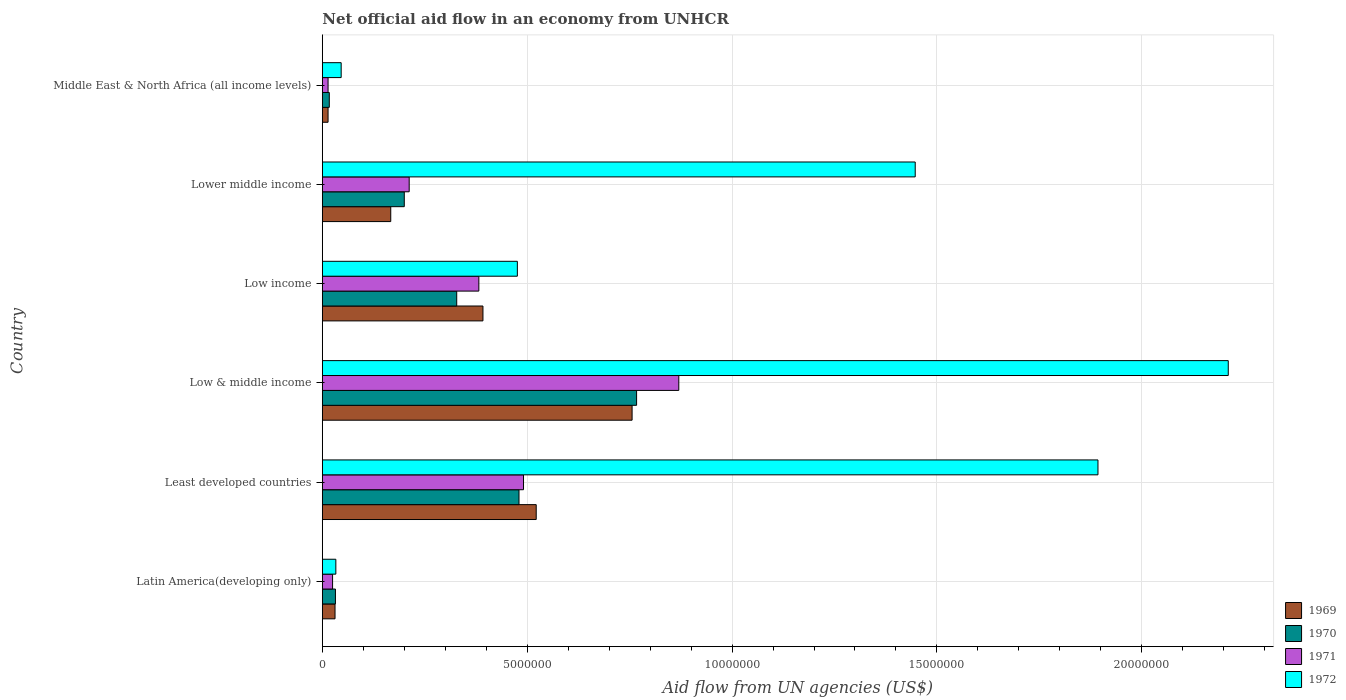How many groups of bars are there?
Provide a succinct answer. 6. Are the number of bars on each tick of the Y-axis equal?
Your response must be concise. Yes. How many bars are there on the 1st tick from the bottom?
Offer a terse response. 4. What is the label of the 1st group of bars from the top?
Ensure brevity in your answer.  Middle East & North Africa (all income levels). What is the net official aid flow in 1972 in Middle East & North Africa (all income levels)?
Offer a terse response. 4.60e+05. Across all countries, what is the maximum net official aid flow in 1969?
Give a very brief answer. 7.56e+06. Across all countries, what is the minimum net official aid flow in 1970?
Your answer should be compact. 1.70e+05. In which country was the net official aid flow in 1971 maximum?
Your answer should be compact. Low & middle income. In which country was the net official aid flow in 1972 minimum?
Give a very brief answer. Latin America(developing only). What is the total net official aid flow in 1971 in the graph?
Offer a very short reply. 1.99e+07. What is the difference between the net official aid flow in 1969 in Low income and that in Middle East & North Africa (all income levels)?
Make the answer very short. 3.78e+06. What is the difference between the net official aid flow in 1970 in Least developed countries and the net official aid flow in 1969 in Low & middle income?
Offer a terse response. -2.76e+06. What is the average net official aid flow in 1972 per country?
Offer a very short reply. 1.02e+07. What is the difference between the net official aid flow in 1970 and net official aid flow in 1971 in Low & middle income?
Make the answer very short. -1.03e+06. In how many countries, is the net official aid flow in 1971 greater than 19000000 US$?
Offer a very short reply. 0. What is the ratio of the net official aid flow in 1971 in Latin America(developing only) to that in Low & middle income?
Ensure brevity in your answer.  0.03. Is the net official aid flow in 1972 in Latin America(developing only) less than that in Least developed countries?
Make the answer very short. Yes. What is the difference between the highest and the second highest net official aid flow in 1969?
Make the answer very short. 2.34e+06. What is the difference between the highest and the lowest net official aid flow in 1972?
Make the answer very short. 2.18e+07. What does the 4th bar from the top in Middle East & North Africa (all income levels) represents?
Offer a very short reply. 1969. What does the 1st bar from the bottom in Lower middle income represents?
Your response must be concise. 1969. Is it the case that in every country, the sum of the net official aid flow in 1969 and net official aid flow in 1970 is greater than the net official aid flow in 1972?
Keep it short and to the point. No. Are all the bars in the graph horizontal?
Your answer should be very brief. Yes. What is the difference between two consecutive major ticks on the X-axis?
Provide a succinct answer. 5.00e+06. Are the values on the major ticks of X-axis written in scientific E-notation?
Your response must be concise. No. Does the graph contain grids?
Your answer should be very brief. Yes. How many legend labels are there?
Provide a short and direct response. 4. How are the legend labels stacked?
Your response must be concise. Vertical. What is the title of the graph?
Offer a terse response. Net official aid flow in an economy from UNHCR. What is the label or title of the X-axis?
Provide a short and direct response. Aid flow from UN agencies (US$). What is the Aid flow from UN agencies (US$) in 1970 in Latin America(developing only)?
Your answer should be very brief. 3.20e+05. What is the Aid flow from UN agencies (US$) of 1969 in Least developed countries?
Offer a terse response. 5.22e+06. What is the Aid flow from UN agencies (US$) in 1970 in Least developed countries?
Offer a very short reply. 4.80e+06. What is the Aid flow from UN agencies (US$) of 1971 in Least developed countries?
Your answer should be very brief. 4.91e+06. What is the Aid flow from UN agencies (US$) in 1972 in Least developed countries?
Give a very brief answer. 1.89e+07. What is the Aid flow from UN agencies (US$) of 1969 in Low & middle income?
Provide a succinct answer. 7.56e+06. What is the Aid flow from UN agencies (US$) of 1970 in Low & middle income?
Make the answer very short. 7.67e+06. What is the Aid flow from UN agencies (US$) of 1971 in Low & middle income?
Ensure brevity in your answer.  8.70e+06. What is the Aid flow from UN agencies (US$) of 1972 in Low & middle income?
Provide a succinct answer. 2.21e+07. What is the Aid flow from UN agencies (US$) of 1969 in Low income?
Offer a terse response. 3.92e+06. What is the Aid flow from UN agencies (US$) of 1970 in Low income?
Your answer should be very brief. 3.28e+06. What is the Aid flow from UN agencies (US$) of 1971 in Low income?
Make the answer very short. 3.82e+06. What is the Aid flow from UN agencies (US$) of 1972 in Low income?
Provide a short and direct response. 4.76e+06. What is the Aid flow from UN agencies (US$) in 1969 in Lower middle income?
Offer a terse response. 1.67e+06. What is the Aid flow from UN agencies (US$) of 1971 in Lower middle income?
Give a very brief answer. 2.12e+06. What is the Aid flow from UN agencies (US$) of 1972 in Lower middle income?
Offer a very short reply. 1.45e+07. What is the Aid flow from UN agencies (US$) in 1970 in Middle East & North Africa (all income levels)?
Ensure brevity in your answer.  1.70e+05. Across all countries, what is the maximum Aid flow from UN agencies (US$) of 1969?
Provide a succinct answer. 7.56e+06. Across all countries, what is the maximum Aid flow from UN agencies (US$) of 1970?
Ensure brevity in your answer.  7.67e+06. Across all countries, what is the maximum Aid flow from UN agencies (US$) in 1971?
Offer a very short reply. 8.70e+06. Across all countries, what is the maximum Aid flow from UN agencies (US$) of 1972?
Your answer should be very brief. 2.21e+07. Across all countries, what is the minimum Aid flow from UN agencies (US$) in 1971?
Provide a short and direct response. 1.40e+05. What is the total Aid flow from UN agencies (US$) in 1969 in the graph?
Your response must be concise. 1.88e+07. What is the total Aid flow from UN agencies (US$) of 1970 in the graph?
Make the answer very short. 1.82e+07. What is the total Aid flow from UN agencies (US$) of 1971 in the graph?
Your answer should be compact. 1.99e+07. What is the total Aid flow from UN agencies (US$) of 1972 in the graph?
Give a very brief answer. 6.11e+07. What is the difference between the Aid flow from UN agencies (US$) of 1969 in Latin America(developing only) and that in Least developed countries?
Make the answer very short. -4.91e+06. What is the difference between the Aid flow from UN agencies (US$) of 1970 in Latin America(developing only) and that in Least developed countries?
Your response must be concise. -4.48e+06. What is the difference between the Aid flow from UN agencies (US$) of 1971 in Latin America(developing only) and that in Least developed countries?
Make the answer very short. -4.66e+06. What is the difference between the Aid flow from UN agencies (US$) in 1972 in Latin America(developing only) and that in Least developed countries?
Offer a very short reply. -1.86e+07. What is the difference between the Aid flow from UN agencies (US$) in 1969 in Latin America(developing only) and that in Low & middle income?
Give a very brief answer. -7.25e+06. What is the difference between the Aid flow from UN agencies (US$) in 1970 in Latin America(developing only) and that in Low & middle income?
Provide a succinct answer. -7.35e+06. What is the difference between the Aid flow from UN agencies (US$) of 1971 in Latin America(developing only) and that in Low & middle income?
Provide a succinct answer. -8.45e+06. What is the difference between the Aid flow from UN agencies (US$) in 1972 in Latin America(developing only) and that in Low & middle income?
Offer a very short reply. -2.18e+07. What is the difference between the Aid flow from UN agencies (US$) of 1969 in Latin America(developing only) and that in Low income?
Provide a succinct answer. -3.61e+06. What is the difference between the Aid flow from UN agencies (US$) in 1970 in Latin America(developing only) and that in Low income?
Provide a succinct answer. -2.96e+06. What is the difference between the Aid flow from UN agencies (US$) in 1971 in Latin America(developing only) and that in Low income?
Provide a short and direct response. -3.57e+06. What is the difference between the Aid flow from UN agencies (US$) of 1972 in Latin America(developing only) and that in Low income?
Ensure brevity in your answer.  -4.43e+06. What is the difference between the Aid flow from UN agencies (US$) of 1969 in Latin America(developing only) and that in Lower middle income?
Provide a succinct answer. -1.36e+06. What is the difference between the Aid flow from UN agencies (US$) of 1970 in Latin America(developing only) and that in Lower middle income?
Your answer should be very brief. -1.68e+06. What is the difference between the Aid flow from UN agencies (US$) in 1971 in Latin America(developing only) and that in Lower middle income?
Keep it short and to the point. -1.87e+06. What is the difference between the Aid flow from UN agencies (US$) in 1972 in Latin America(developing only) and that in Lower middle income?
Make the answer very short. -1.41e+07. What is the difference between the Aid flow from UN agencies (US$) of 1969 in Latin America(developing only) and that in Middle East & North Africa (all income levels)?
Keep it short and to the point. 1.70e+05. What is the difference between the Aid flow from UN agencies (US$) of 1969 in Least developed countries and that in Low & middle income?
Make the answer very short. -2.34e+06. What is the difference between the Aid flow from UN agencies (US$) in 1970 in Least developed countries and that in Low & middle income?
Offer a terse response. -2.87e+06. What is the difference between the Aid flow from UN agencies (US$) in 1971 in Least developed countries and that in Low & middle income?
Ensure brevity in your answer.  -3.79e+06. What is the difference between the Aid flow from UN agencies (US$) in 1972 in Least developed countries and that in Low & middle income?
Your answer should be very brief. -3.18e+06. What is the difference between the Aid flow from UN agencies (US$) in 1969 in Least developed countries and that in Low income?
Offer a very short reply. 1.30e+06. What is the difference between the Aid flow from UN agencies (US$) in 1970 in Least developed countries and that in Low income?
Ensure brevity in your answer.  1.52e+06. What is the difference between the Aid flow from UN agencies (US$) in 1971 in Least developed countries and that in Low income?
Provide a succinct answer. 1.09e+06. What is the difference between the Aid flow from UN agencies (US$) in 1972 in Least developed countries and that in Low income?
Offer a very short reply. 1.42e+07. What is the difference between the Aid flow from UN agencies (US$) in 1969 in Least developed countries and that in Lower middle income?
Your response must be concise. 3.55e+06. What is the difference between the Aid flow from UN agencies (US$) of 1970 in Least developed countries and that in Lower middle income?
Give a very brief answer. 2.80e+06. What is the difference between the Aid flow from UN agencies (US$) of 1971 in Least developed countries and that in Lower middle income?
Your answer should be compact. 2.79e+06. What is the difference between the Aid flow from UN agencies (US$) in 1972 in Least developed countries and that in Lower middle income?
Your answer should be compact. 4.46e+06. What is the difference between the Aid flow from UN agencies (US$) in 1969 in Least developed countries and that in Middle East & North Africa (all income levels)?
Provide a short and direct response. 5.08e+06. What is the difference between the Aid flow from UN agencies (US$) in 1970 in Least developed countries and that in Middle East & North Africa (all income levels)?
Provide a succinct answer. 4.63e+06. What is the difference between the Aid flow from UN agencies (US$) in 1971 in Least developed countries and that in Middle East & North Africa (all income levels)?
Ensure brevity in your answer.  4.77e+06. What is the difference between the Aid flow from UN agencies (US$) in 1972 in Least developed countries and that in Middle East & North Africa (all income levels)?
Provide a succinct answer. 1.85e+07. What is the difference between the Aid flow from UN agencies (US$) in 1969 in Low & middle income and that in Low income?
Your answer should be very brief. 3.64e+06. What is the difference between the Aid flow from UN agencies (US$) of 1970 in Low & middle income and that in Low income?
Offer a terse response. 4.39e+06. What is the difference between the Aid flow from UN agencies (US$) of 1971 in Low & middle income and that in Low income?
Give a very brief answer. 4.88e+06. What is the difference between the Aid flow from UN agencies (US$) of 1972 in Low & middle income and that in Low income?
Give a very brief answer. 1.74e+07. What is the difference between the Aid flow from UN agencies (US$) in 1969 in Low & middle income and that in Lower middle income?
Ensure brevity in your answer.  5.89e+06. What is the difference between the Aid flow from UN agencies (US$) in 1970 in Low & middle income and that in Lower middle income?
Your response must be concise. 5.67e+06. What is the difference between the Aid flow from UN agencies (US$) in 1971 in Low & middle income and that in Lower middle income?
Provide a short and direct response. 6.58e+06. What is the difference between the Aid flow from UN agencies (US$) in 1972 in Low & middle income and that in Lower middle income?
Give a very brief answer. 7.64e+06. What is the difference between the Aid flow from UN agencies (US$) of 1969 in Low & middle income and that in Middle East & North Africa (all income levels)?
Keep it short and to the point. 7.42e+06. What is the difference between the Aid flow from UN agencies (US$) of 1970 in Low & middle income and that in Middle East & North Africa (all income levels)?
Make the answer very short. 7.50e+06. What is the difference between the Aid flow from UN agencies (US$) in 1971 in Low & middle income and that in Middle East & North Africa (all income levels)?
Offer a terse response. 8.56e+06. What is the difference between the Aid flow from UN agencies (US$) in 1972 in Low & middle income and that in Middle East & North Africa (all income levels)?
Offer a very short reply. 2.16e+07. What is the difference between the Aid flow from UN agencies (US$) of 1969 in Low income and that in Lower middle income?
Give a very brief answer. 2.25e+06. What is the difference between the Aid flow from UN agencies (US$) of 1970 in Low income and that in Lower middle income?
Provide a succinct answer. 1.28e+06. What is the difference between the Aid flow from UN agencies (US$) of 1971 in Low income and that in Lower middle income?
Provide a succinct answer. 1.70e+06. What is the difference between the Aid flow from UN agencies (US$) of 1972 in Low income and that in Lower middle income?
Make the answer very short. -9.71e+06. What is the difference between the Aid flow from UN agencies (US$) of 1969 in Low income and that in Middle East & North Africa (all income levels)?
Keep it short and to the point. 3.78e+06. What is the difference between the Aid flow from UN agencies (US$) in 1970 in Low income and that in Middle East & North Africa (all income levels)?
Provide a succinct answer. 3.11e+06. What is the difference between the Aid flow from UN agencies (US$) in 1971 in Low income and that in Middle East & North Africa (all income levels)?
Offer a very short reply. 3.68e+06. What is the difference between the Aid flow from UN agencies (US$) in 1972 in Low income and that in Middle East & North Africa (all income levels)?
Provide a short and direct response. 4.30e+06. What is the difference between the Aid flow from UN agencies (US$) of 1969 in Lower middle income and that in Middle East & North Africa (all income levels)?
Your answer should be compact. 1.53e+06. What is the difference between the Aid flow from UN agencies (US$) of 1970 in Lower middle income and that in Middle East & North Africa (all income levels)?
Make the answer very short. 1.83e+06. What is the difference between the Aid flow from UN agencies (US$) of 1971 in Lower middle income and that in Middle East & North Africa (all income levels)?
Your answer should be very brief. 1.98e+06. What is the difference between the Aid flow from UN agencies (US$) of 1972 in Lower middle income and that in Middle East & North Africa (all income levels)?
Offer a terse response. 1.40e+07. What is the difference between the Aid flow from UN agencies (US$) in 1969 in Latin America(developing only) and the Aid flow from UN agencies (US$) in 1970 in Least developed countries?
Keep it short and to the point. -4.49e+06. What is the difference between the Aid flow from UN agencies (US$) in 1969 in Latin America(developing only) and the Aid flow from UN agencies (US$) in 1971 in Least developed countries?
Give a very brief answer. -4.60e+06. What is the difference between the Aid flow from UN agencies (US$) in 1969 in Latin America(developing only) and the Aid flow from UN agencies (US$) in 1972 in Least developed countries?
Your answer should be compact. -1.86e+07. What is the difference between the Aid flow from UN agencies (US$) in 1970 in Latin America(developing only) and the Aid flow from UN agencies (US$) in 1971 in Least developed countries?
Provide a short and direct response. -4.59e+06. What is the difference between the Aid flow from UN agencies (US$) in 1970 in Latin America(developing only) and the Aid flow from UN agencies (US$) in 1972 in Least developed countries?
Give a very brief answer. -1.86e+07. What is the difference between the Aid flow from UN agencies (US$) in 1971 in Latin America(developing only) and the Aid flow from UN agencies (US$) in 1972 in Least developed countries?
Offer a very short reply. -1.87e+07. What is the difference between the Aid flow from UN agencies (US$) of 1969 in Latin America(developing only) and the Aid flow from UN agencies (US$) of 1970 in Low & middle income?
Provide a succinct answer. -7.36e+06. What is the difference between the Aid flow from UN agencies (US$) in 1969 in Latin America(developing only) and the Aid flow from UN agencies (US$) in 1971 in Low & middle income?
Ensure brevity in your answer.  -8.39e+06. What is the difference between the Aid flow from UN agencies (US$) of 1969 in Latin America(developing only) and the Aid flow from UN agencies (US$) of 1972 in Low & middle income?
Offer a terse response. -2.18e+07. What is the difference between the Aid flow from UN agencies (US$) in 1970 in Latin America(developing only) and the Aid flow from UN agencies (US$) in 1971 in Low & middle income?
Provide a succinct answer. -8.38e+06. What is the difference between the Aid flow from UN agencies (US$) in 1970 in Latin America(developing only) and the Aid flow from UN agencies (US$) in 1972 in Low & middle income?
Keep it short and to the point. -2.18e+07. What is the difference between the Aid flow from UN agencies (US$) in 1971 in Latin America(developing only) and the Aid flow from UN agencies (US$) in 1972 in Low & middle income?
Your answer should be compact. -2.19e+07. What is the difference between the Aid flow from UN agencies (US$) in 1969 in Latin America(developing only) and the Aid flow from UN agencies (US$) in 1970 in Low income?
Provide a succinct answer. -2.97e+06. What is the difference between the Aid flow from UN agencies (US$) of 1969 in Latin America(developing only) and the Aid flow from UN agencies (US$) of 1971 in Low income?
Your response must be concise. -3.51e+06. What is the difference between the Aid flow from UN agencies (US$) of 1969 in Latin America(developing only) and the Aid flow from UN agencies (US$) of 1972 in Low income?
Offer a very short reply. -4.45e+06. What is the difference between the Aid flow from UN agencies (US$) in 1970 in Latin America(developing only) and the Aid flow from UN agencies (US$) in 1971 in Low income?
Make the answer very short. -3.50e+06. What is the difference between the Aid flow from UN agencies (US$) in 1970 in Latin America(developing only) and the Aid flow from UN agencies (US$) in 1972 in Low income?
Make the answer very short. -4.44e+06. What is the difference between the Aid flow from UN agencies (US$) of 1971 in Latin America(developing only) and the Aid flow from UN agencies (US$) of 1972 in Low income?
Your answer should be very brief. -4.51e+06. What is the difference between the Aid flow from UN agencies (US$) in 1969 in Latin America(developing only) and the Aid flow from UN agencies (US$) in 1970 in Lower middle income?
Your response must be concise. -1.69e+06. What is the difference between the Aid flow from UN agencies (US$) in 1969 in Latin America(developing only) and the Aid flow from UN agencies (US$) in 1971 in Lower middle income?
Make the answer very short. -1.81e+06. What is the difference between the Aid flow from UN agencies (US$) in 1969 in Latin America(developing only) and the Aid flow from UN agencies (US$) in 1972 in Lower middle income?
Offer a very short reply. -1.42e+07. What is the difference between the Aid flow from UN agencies (US$) in 1970 in Latin America(developing only) and the Aid flow from UN agencies (US$) in 1971 in Lower middle income?
Offer a very short reply. -1.80e+06. What is the difference between the Aid flow from UN agencies (US$) of 1970 in Latin America(developing only) and the Aid flow from UN agencies (US$) of 1972 in Lower middle income?
Your answer should be very brief. -1.42e+07. What is the difference between the Aid flow from UN agencies (US$) in 1971 in Latin America(developing only) and the Aid flow from UN agencies (US$) in 1972 in Lower middle income?
Your answer should be compact. -1.42e+07. What is the difference between the Aid flow from UN agencies (US$) in 1969 in Latin America(developing only) and the Aid flow from UN agencies (US$) in 1970 in Middle East & North Africa (all income levels)?
Make the answer very short. 1.40e+05. What is the difference between the Aid flow from UN agencies (US$) in 1969 in Latin America(developing only) and the Aid flow from UN agencies (US$) in 1972 in Middle East & North Africa (all income levels)?
Offer a very short reply. -1.50e+05. What is the difference between the Aid flow from UN agencies (US$) of 1970 in Latin America(developing only) and the Aid flow from UN agencies (US$) of 1972 in Middle East & North Africa (all income levels)?
Keep it short and to the point. -1.40e+05. What is the difference between the Aid flow from UN agencies (US$) in 1971 in Latin America(developing only) and the Aid flow from UN agencies (US$) in 1972 in Middle East & North Africa (all income levels)?
Keep it short and to the point. -2.10e+05. What is the difference between the Aid flow from UN agencies (US$) of 1969 in Least developed countries and the Aid flow from UN agencies (US$) of 1970 in Low & middle income?
Provide a succinct answer. -2.45e+06. What is the difference between the Aid flow from UN agencies (US$) of 1969 in Least developed countries and the Aid flow from UN agencies (US$) of 1971 in Low & middle income?
Provide a short and direct response. -3.48e+06. What is the difference between the Aid flow from UN agencies (US$) of 1969 in Least developed countries and the Aid flow from UN agencies (US$) of 1972 in Low & middle income?
Ensure brevity in your answer.  -1.69e+07. What is the difference between the Aid flow from UN agencies (US$) of 1970 in Least developed countries and the Aid flow from UN agencies (US$) of 1971 in Low & middle income?
Give a very brief answer. -3.90e+06. What is the difference between the Aid flow from UN agencies (US$) of 1970 in Least developed countries and the Aid flow from UN agencies (US$) of 1972 in Low & middle income?
Make the answer very short. -1.73e+07. What is the difference between the Aid flow from UN agencies (US$) of 1971 in Least developed countries and the Aid flow from UN agencies (US$) of 1972 in Low & middle income?
Your response must be concise. -1.72e+07. What is the difference between the Aid flow from UN agencies (US$) in 1969 in Least developed countries and the Aid flow from UN agencies (US$) in 1970 in Low income?
Give a very brief answer. 1.94e+06. What is the difference between the Aid flow from UN agencies (US$) of 1969 in Least developed countries and the Aid flow from UN agencies (US$) of 1971 in Low income?
Provide a succinct answer. 1.40e+06. What is the difference between the Aid flow from UN agencies (US$) in 1969 in Least developed countries and the Aid flow from UN agencies (US$) in 1972 in Low income?
Keep it short and to the point. 4.60e+05. What is the difference between the Aid flow from UN agencies (US$) of 1970 in Least developed countries and the Aid flow from UN agencies (US$) of 1971 in Low income?
Make the answer very short. 9.80e+05. What is the difference between the Aid flow from UN agencies (US$) in 1970 in Least developed countries and the Aid flow from UN agencies (US$) in 1972 in Low income?
Make the answer very short. 4.00e+04. What is the difference between the Aid flow from UN agencies (US$) of 1971 in Least developed countries and the Aid flow from UN agencies (US$) of 1972 in Low income?
Your answer should be compact. 1.50e+05. What is the difference between the Aid flow from UN agencies (US$) of 1969 in Least developed countries and the Aid flow from UN agencies (US$) of 1970 in Lower middle income?
Offer a terse response. 3.22e+06. What is the difference between the Aid flow from UN agencies (US$) in 1969 in Least developed countries and the Aid flow from UN agencies (US$) in 1971 in Lower middle income?
Your answer should be very brief. 3.10e+06. What is the difference between the Aid flow from UN agencies (US$) of 1969 in Least developed countries and the Aid flow from UN agencies (US$) of 1972 in Lower middle income?
Your answer should be very brief. -9.25e+06. What is the difference between the Aid flow from UN agencies (US$) of 1970 in Least developed countries and the Aid flow from UN agencies (US$) of 1971 in Lower middle income?
Ensure brevity in your answer.  2.68e+06. What is the difference between the Aid flow from UN agencies (US$) of 1970 in Least developed countries and the Aid flow from UN agencies (US$) of 1972 in Lower middle income?
Make the answer very short. -9.67e+06. What is the difference between the Aid flow from UN agencies (US$) of 1971 in Least developed countries and the Aid flow from UN agencies (US$) of 1972 in Lower middle income?
Your response must be concise. -9.56e+06. What is the difference between the Aid flow from UN agencies (US$) of 1969 in Least developed countries and the Aid flow from UN agencies (US$) of 1970 in Middle East & North Africa (all income levels)?
Keep it short and to the point. 5.05e+06. What is the difference between the Aid flow from UN agencies (US$) of 1969 in Least developed countries and the Aid flow from UN agencies (US$) of 1971 in Middle East & North Africa (all income levels)?
Offer a terse response. 5.08e+06. What is the difference between the Aid flow from UN agencies (US$) of 1969 in Least developed countries and the Aid flow from UN agencies (US$) of 1972 in Middle East & North Africa (all income levels)?
Provide a short and direct response. 4.76e+06. What is the difference between the Aid flow from UN agencies (US$) in 1970 in Least developed countries and the Aid flow from UN agencies (US$) in 1971 in Middle East & North Africa (all income levels)?
Provide a short and direct response. 4.66e+06. What is the difference between the Aid flow from UN agencies (US$) in 1970 in Least developed countries and the Aid flow from UN agencies (US$) in 1972 in Middle East & North Africa (all income levels)?
Offer a very short reply. 4.34e+06. What is the difference between the Aid flow from UN agencies (US$) of 1971 in Least developed countries and the Aid flow from UN agencies (US$) of 1972 in Middle East & North Africa (all income levels)?
Your response must be concise. 4.45e+06. What is the difference between the Aid flow from UN agencies (US$) in 1969 in Low & middle income and the Aid flow from UN agencies (US$) in 1970 in Low income?
Your answer should be compact. 4.28e+06. What is the difference between the Aid flow from UN agencies (US$) of 1969 in Low & middle income and the Aid flow from UN agencies (US$) of 1971 in Low income?
Make the answer very short. 3.74e+06. What is the difference between the Aid flow from UN agencies (US$) of 1969 in Low & middle income and the Aid flow from UN agencies (US$) of 1972 in Low income?
Make the answer very short. 2.80e+06. What is the difference between the Aid flow from UN agencies (US$) of 1970 in Low & middle income and the Aid flow from UN agencies (US$) of 1971 in Low income?
Offer a terse response. 3.85e+06. What is the difference between the Aid flow from UN agencies (US$) of 1970 in Low & middle income and the Aid flow from UN agencies (US$) of 1972 in Low income?
Ensure brevity in your answer.  2.91e+06. What is the difference between the Aid flow from UN agencies (US$) in 1971 in Low & middle income and the Aid flow from UN agencies (US$) in 1972 in Low income?
Give a very brief answer. 3.94e+06. What is the difference between the Aid flow from UN agencies (US$) in 1969 in Low & middle income and the Aid flow from UN agencies (US$) in 1970 in Lower middle income?
Provide a succinct answer. 5.56e+06. What is the difference between the Aid flow from UN agencies (US$) of 1969 in Low & middle income and the Aid flow from UN agencies (US$) of 1971 in Lower middle income?
Your response must be concise. 5.44e+06. What is the difference between the Aid flow from UN agencies (US$) of 1969 in Low & middle income and the Aid flow from UN agencies (US$) of 1972 in Lower middle income?
Ensure brevity in your answer.  -6.91e+06. What is the difference between the Aid flow from UN agencies (US$) in 1970 in Low & middle income and the Aid flow from UN agencies (US$) in 1971 in Lower middle income?
Your response must be concise. 5.55e+06. What is the difference between the Aid flow from UN agencies (US$) in 1970 in Low & middle income and the Aid flow from UN agencies (US$) in 1972 in Lower middle income?
Offer a terse response. -6.80e+06. What is the difference between the Aid flow from UN agencies (US$) of 1971 in Low & middle income and the Aid flow from UN agencies (US$) of 1972 in Lower middle income?
Provide a short and direct response. -5.77e+06. What is the difference between the Aid flow from UN agencies (US$) in 1969 in Low & middle income and the Aid flow from UN agencies (US$) in 1970 in Middle East & North Africa (all income levels)?
Your answer should be compact. 7.39e+06. What is the difference between the Aid flow from UN agencies (US$) in 1969 in Low & middle income and the Aid flow from UN agencies (US$) in 1971 in Middle East & North Africa (all income levels)?
Offer a terse response. 7.42e+06. What is the difference between the Aid flow from UN agencies (US$) of 1969 in Low & middle income and the Aid flow from UN agencies (US$) of 1972 in Middle East & North Africa (all income levels)?
Your answer should be very brief. 7.10e+06. What is the difference between the Aid flow from UN agencies (US$) in 1970 in Low & middle income and the Aid flow from UN agencies (US$) in 1971 in Middle East & North Africa (all income levels)?
Your response must be concise. 7.53e+06. What is the difference between the Aid flow from UN agencies (US$) of 1970 in Low & middle income and the Aid flow from UN agencies (US$) of 1972 in Middle East & North Africa (all income levels)?
Make the answer very short. 7.21e+06. What is the difference between the Aid flow from UN agencies (US$) of 1971 in Low & middle income and the Aid flow from UN agencies (US$) of 1972 in Middle East & North Africa (all income levels)?
Your answer should be very brief. 8.24e+06. What is the difference between the Aid flow from UN agencies (US$) in 1969 in Low income and the Aid flow from UN agencies (US$) in 1970 in Lower middle income?
Your response must be concise. 1.92e+06. What is the difference between the Aid flow from UN agencies (US$) of 1969 in Low income and the Aid flow from UN agencies (US$) of 1971 in Lower middle income?
Your response must be concise. 1.80e+06. What is the difference between the Aid flow from UN agencies (US$) in 1969 in Low income and the Aid flow from UN agencies (US$) in 1972 in Lower middle income?
Offer a very short reply. -1.06e+07. What is the difference between the Aid flow from UN agencies (US$) in 1970 in Low income and the Aid flow from UN agencies (US$) in 1971 in Lower middle income?
Ensure brevity in your answer.  1.16e+06. What is the difference between the Aid flow from UN agencies (US$) in 1970 in Low income and the Aid flow from UN agencies (US$) in 1972 in Lower middle income?
Offer a very short reply. -1.12e+07. What is the difference between the Aid flow from UN agencies (US$) in 1971 in Low income and the Aid flow from UN agencies (US$) in 1972 in Lower middle income?
Provide a short and direct response. -1.06e+07. What is the difference between the Aid flow from UN agencies (US$) of 1969 in Low income and the Aid flow from UN agencies (US$) of 1970 in Middle East & North Africa (all income levels)?
Offer a very short reply. 3.75e+06. What is the difference between the Aid flow from UN agencies (US$) of 1969 in Low income and the Aid flow from UN agencies (US$) of 1971 in Middle East & North Africa (all income levels)?
Offer a very short reply. 3.78e+06. What is the difference between the Aid flow from UN agencies (US$) in 1969 in Low income and the Aid flow from UN agencies (US$) in 1972 in Middle East & North Africa (all income levels)?
Your answer should be compact. 3.46e+06. What is the difference between the Aid flow from UN agencies (US$) in 1970 in Low income and the Aid flow from UN agencies (US$) in 1971 in Middle East & North Africa (all income levels)?
Offer a very short reply. 3.14e+06. What is the difference between the Aid flow from UN agencies (US$) of 1970 in Low income and the Aid flow from UN agencies (US$) of 1972 in Middle East & North Africa (all income levels)?
Give a very brief answer. 2.82e+06. What is the difference between the Aid flow from UN agencies (US$) in 1971 in Low income and the Aid flow from UN agencies (US$) in 1972 in Middle East & North Africa (all income levels)?
Keep it short and to the point. 3.36e+06. What is the difference between the Aid flow from UN agencies (US$) in 1969 in Lower middle income and the Aid flow from UN agencies (US$) in 1970 in Middle East & North Africa (all income levels)?
Give a very brief answer. 1.50e+06. What is the difference between the Aid flow from UN agencies (US$) in 1969 in Lower middle income and the Aid flow from UN agencies (US$) in 1971 in Middle East & North Africa (all income levels)?
Give a very brief answer. 1.53e+06. What is the difference between the Aid flow from UN agencies (US$) in 1969 in Lower middle income and the Aid flow from UN agencies (US$) in 1972 in Middle East & North Africa (all income levels)?
Ensure brevity in your answer.  1.21e+06. What is the difference between the Aid flow from UN agencies (US$) in 1970 in Lower middle income and the Aid flow from UN agencies (US$) in 1971 in Middle East & North Africa (all income levels)?
Your answer should be compact. 1.86e+06. What is the difference between the Aid flow from UN agencies (US$) of 1970 in Lower middle income and the Aid flow from UN agencies (US$) of 1972 in Middle East & North Africa (all income levels)?
Make the answer very short. 1.54e+06. What is the difference between the Aid flow from UN agencies (US$) in 1971 in Lower middle income and the Aid flow from UN agencies (US$) in 1972 in Middle East & North Africa (all income levels)?
Offer a very short reply. 1.66e+06. What is the average Aid flow from UN agencies (US$) in 1969 per country?
Make the answer very short. 3.14e+06. What is the average Aid flow from UN agencies (US$) of 1970 per country?
Your answer should be compact. 3.04e+06. What is the average Aid flow from UN agencies (US$) of 1971 per country?
Make the answer very short. 3.32e+06. What is the average Aid flow from UN agencies (US$) of 1972 per country?
Offer a terse response. 1.02e+07. What is the difference between the Aid flow from UN agencies (US$) in 1969 and Aid flow from UN agencies (US$) in 1970 in Latin America(developing only)?
Make the answer very short. -10000. What is the difference between the Aid flow from UN agencies (US$) in 1969 and Aid flow from UN agencies (US$) in 1971 in Latin America(developing only)?
Offer a very short reply. 6.00e+04. What is the difference between the Aid flow from UN agencies (US$) in 1970 and Aid flow from UN agencies (US$) in 1971 in Latin America(developing only)?
Offer a terse response. 7.00e+04. What is the difference between the Aid flow from UN agencies (US$) of 1970 and Aid flow from UN agencies (US$) of 1972 in Latin America(developing only)?
Keep it short and to the point. -10000. What is the difference between the Aid flow from UN agencies (US$) in 1971 and Aid flow from UN agencies (US$) in 1972 in Latin America(developing only)?
Your answer should be very brief. -8.00e+04. What is the difference between the Aid flow from UN agencies (US$) of 1969 and Aid flow from UN agencies (US$) of 1970 in Least developed countries?
Offer a terse response. 4.20e+05. What is the difference between the Aid flow from UN agencies (US$) in 1969 and Aid flow from UN agencies (US$) in 1972 in Least developed countries?
Provide a succinct answer. -1.37e+07. What is the difference between the Aid flow from UN agencies (US$) of 1970 and Aid flow from UN agencies (US$) of 1972 in Least developed countries?
Keep it short and to the point. -1.41e+07. What is the difference between the Aid flow from UN agencies (US$) in 1971 and Aid flow from UN agencies (US$) in 1972 in Least developed countries?
Provide a short and direct response. -1.40e+07. What is the difference between the Aid flow from UN agencies (US$) of 1969 and Aid flow from UN agencies (US$) of 1970 in Low & middle income?
Provide a short and direct response. -1.10e+05. What is the difference between the Aid flow from UN agencies (US$) in 1969 and Aid flow from UN agencies (US$) in 1971 in Low & middle income?
Ensure brevity in your answer.  -1.14e+06. What is the difference between the Aid flow from UN agencies (US$) in 1969 and Aid flow from UN agencies (US$) in 1972 in Low & middle income?
Give a very brief answer. -1.46e+07. What is the difference between the Aid flow from UN agencies (US$) in 1970 and Aid flow from UN agencies (US$) in 1971 in Low & middle income?
Give a very brief answer. -1.03e+06. What is the difference between the Aid flow from UN agencies (US$) in 1970 and Aid flow from UN agencies (US$) in 1972 in Low & middle income?
Your answer should be very brief. -1.44e+07. What is the difference between the Aid flow from UN agencies (US$) of 1971 and Aid flow from UN agencies (US$) of 1972 in Low & middle income?
Provide a succinct answer. -1.34e+07. What is the difference between the Aid flow from UN agencies (US$) in 1969 and Aid flow from UN agencies (US$) in 1970 in Low income?
Provide a short and direct response. 6.40e+05. What is the difference between the Aid flow from UN agencies (US$) in 1969 and Aid flow from UN agencies (US$) in 1971 in Low income?
Keep it short and to the point. 1.00e+05. What is the difference between the Aid flow from UN agencies (US$) in 1969 and Aid flow from UN agencies (US$) in 1972 in Low income?
Your response must be concise. -8.40e+05. What is the difference between the Aid flow from UN agencies (US$) in 1970 and Aid flow from UN agencies (US$) in 1971 in Low income?
Your answer should be compact. -5.40e+05. What is the difference between the Aid flow from UN agencies (US$) of 1970 and Aid flow from UN agencies (US$) of 1972 in Low income?
Offer a terse response. -1.48e+06. What is the difference between the Aid flow from UN agencies (US$) in 1971 and Aid flow from UN agencies (US$) in 1972 in Low income?
Your answer should be very brief. -9.40e+05. What is the difference between the Aid flow from UN agencies (US$) of 1969 and Aid flow from UN agencies (US$) of 1970 in Lower middle income?
Offer a terse response. -3.30e+05. What is the difference between the Aid flow from UN agencies (US$) of 1969 and Aid flow from UN agencies (US$) of 1971 in Lower middle income?
Make the answer very short. -4.50e+05. What is the difference between the Aid flow from UN agencies (US$) of 1969 and Aid flow from UN agencies (US$) of 1972 in Lower middle income?
Keep it short and to the point. -1.28e+07. What is the difference between the Aid flow from UN agencies (US$) of 1970 and Aid flow from UN agencies (US$) of 1972 in Lower middle income?
Provide a succinct answer. -1.25e+07. What is the difference between the Aid flow from UN agencies (US$) in 1971 and Aid flow from UN agencies (US$) in 1972 in Lower middle income?
Offer a terse response. -1.24e+07. What is the difference between the Aid flow from UN agencies (US$) in 1969 and Aid flow from UN agencies (US$) in 1971 in Middle East & North Africa (all income levels)?
Offer a terse response. 0. What is the difference between the Aid flow from UN agencies (US$) in 1969 and Aid flow from UN agencies (US$) in 1972 in Middle East & North Africa (all income levels)?
Give a very brief answer. -3.20e+05. What is the difference between the Aid flow from UN agencies (US$) in 1970 and Aid flow from UN agencies (US$) in 1971 in Middle East & North Africa (all income levels)?
Provide a short and direct response. 3.00e+04. What is the difference between the Aid flow from UN agencies (US$) in 1970 and Aid flow from UN agencies (US$) in 1972 in Middle East & North Africa (all income levels)?
Keep it short and to the point. -2.90e+05. What is the difference between the Aid flow from UN agencies (US$) in 1971 and Aid flow from UN agencies (US$) in 1972 in Middle East & North Africa (all income levels)?
Make the answer very short. -3.20e+05. What is the ratio of the Aid flow from UN agencies (US$) in 1969 in Latin America(developing only) to that in Least developed countries?
Make the answer very short. 0.06. What is the ratio of the Aid flow from UN agencies (US$) in 1970 in Latin America(developing only) to that in Least developed countries?
Ensure brevity in your answer.  0.07. What is the ratio of the Aid flow from UN agencies (US$) in 1971 in Latin America(developing only) to that in Least developed countries?
Provide a short and direct response. 0.05. What is the ratio of the Aid flow from UN agencies (US$) in 1972 in Latin America(developing only) to that in Least developed countries?
Your answer should be compact. 0.02. What is the ratio of the Aid flow from UN agencies (US$) in 1969 in Latin America(developing only) to that in Low & middle income?
Your response must be concise. 0.04. What is the ratio of the Aid flow from UN agencies (US$) of 1970 in Latin America(developing only) to that in Low & middle income?
Your answer should be compact. 0.04. What is the ratio of the Aid flow from UN agencies (US$) of 1971 in Latin America(developing only) to that in Low & middle income?
Give a very brief answer. 0.03. What is the ratio of the Aid flow from UN agencies (US$) of 1972 in Latin America(developing only) to that in Low & middle income?
Offer a terse response. 0.01. What is the ratio of the Aid flow from UN agencies (US$) in 1969 in Latin America(developing only) to that in Low income?
Offer a very short reply. 0.08. What is the ratio of the Aid flow from UN agencies (US$) in 1970 in Latin America(developing only) to that in Low income?
Your answer should be very brief. 0.1. What is the ratio of the Aid flow from UN agencies (US$) of 1971 in Latin America(developing only) to that in Low income?
Provide a short and direct response. 0.07. What is the ratio of the Aid flow from UN agencies (US$) of 1972 in Latin America(developing only) to that in Low income?
Your answer should be very brief. 0.07. What is the ratio of the Aid flow from UN agencies (US$) in 1969 in Latin America(developing only) to that in Lower middle income?
Offer a terse response. 0.19. What is the ratio of the Aid flow from UN agencies (US$) of 1970 in Latin America(developing only) to that in Lower middle income?
Ensure brevity in your answer.  0.16. What is the ratio of the Aid flow from UN agencies (US$) of 1971 in Latin America(developing only) to that in Lower middle income?
Ensure brevity in your answer.  0.12. What is the ratio of the Aid flow from UN agencies (US$) of 1972 in Latin America(developing only) to that in Lower middle income?
Offer a terse response. 0.02. What is the ratio of the Aid flow from UN agencies (US$) of 1969 in Latin America(developing only) to that in Middle East & North Africa (all income levels)?
Offer a very short reply. 2.21. What is the ratio of the Aid flow from UN agencies (US$) of 1970 in Latin America(developing only) to that in Middle East & North Africa (all income levels)?
Your response must be concise. 1.88. What is the ratio of the Aid flow from UN agencies (US$) of 1971 in Latin America(developing only) to that in Middle East & North Africa (all income levels)?
Keep it short and to the point. 1.79. What is the ratio of the Aid flow from UN agencies (US$) of 1972 in Latin America(developing only) to that in Middle East & North Africa (all income levels)?
Your response must be concise. 0.72. What is the ratio of the Aid flow from UN agencies (US$) of 1969 in Least developed countries to that in Low & middle income?
Provide a short and direct response. 0.69. What is the ratio of the Aid flow from UN agencies (US$) in 1970 in Least developed countries to that in Low & middle income?
Provide a succinct answer. 0.63. What is the ratio of the Aid flow from UN agencies (US$) of 1971 in Least developed countries to that in Low & middle income?
Ensure brevity in your answer.  0.56. What is the ratio of the Aid flow from UN agencies (US$) of 1972 in Least developed countries to that in Low & middle income?
Keep it short and to the point. 0.86. What is the ratio of the Aid flow from UN agencies (US$) of 1969 in Least developed countries to that in Low income?
Provide a succinct answer. 1.33. What is the ratio of the Aid flow from UN agencies (US$) in 1970 in Least developed countries to that in Low income?
Your response must be concise. 1.46. What is the ratio of the Aid flow from UN agencies (US$) in 1971 in Least developed countries to that in Low income?
Give a very brief answer. 1.29. What is the ratio of the Aid flow from UN agencies (US$) in 1972 in Least developed countries to that in Low income?
Make the answer very short. 3.98. What is the ratio of the Aid flow from UN agencies (US$) of 1969 in Least developed countries to that in Lower middle income?
Give a very brief answer. 3.13. What is the ratio of the Aid flow from UN agencies (US$) of 1970 in Least developed countries to that in Lower middle income?
Provide a short and direct response. 2.4. What is the ratio of the Aid flow from UN agencies (US$) in 1971 in Least developed countries to that in Lower middle income?
Give a very brief answer. 2.32. What is the ratio of the Aid flow from UN agencies (US$) of 1972 in Least developed countries to that in Lower middle income?
Your answer should be compact. 1.31. What is the ratio of the Aid flow from UN agencies (US$) in 1969 in Least developed countries to that in Middle East & North Africa (all income levels)?
Give a very brief answer. 37.29. What is the ratio of the Aid flow from UN agencies (US$) of 1970 in Least developed countries to that in Middle East & North Africa (all income levels)?
Your answer should be compact. 28.24. What is the ratio of the Aid flow from UN agencies (US$) of 1971 in Least developed countries to that in Middle East & North Africa (all income levels)?
Provide a succinct answer. 35.07. What is the ratio of the Aid flow from UN agencies (US$) of 1972 in Least developed countries to that in Middle East & North Africa (all income levels)?
Offer a terse response. 41.15. What is the ratio of the Aid flow from UN agencies (US$) in 1969 in Low & middle income to that in Low income?
Ensure brevity in your answer.  1.93. What is the ratio of the Aid flow from UN agencies (US$) in 1970 in Low & middle income to that in Low income?
Provide a short and direct response. 2.34. What is the ratio of the Aid flow from UN agencies (US$) of 1971 in Low & middle income to that in Low income?
Offer a terse response. 2.28. What is the ratio of the Aid flow from UN agencies (US$) of 1972 in Low & middle income to that in Low income?
Offer a very short reply. 4.64. What is the ratio of the Aid flow from UN agencies (US$) of 1969 in Low & middle income to that in Lower middle income?
Provide a short and direct response. 4.53. What is the ratio of the Aid flow from UN agencies (US$) in 1970 in Low & middle income to that in Lower middle income?
Provide a succinct answer. 3.83. What is the ratio of the Aid flow from UN agencies (US$) of 1971 in Low & middle income to that in Lower middle income?
Provide a short and direct response. 4.1. What is the ratio of the Aid flow from UN agencies (US$) in 1972 in Low & middle income to that in Lower middle income?
Keep it short and to the point. 1.53. What is the ratio of the Aid flow from UN agencies (US$) of 1969 in Low & middle income to that in Middle East & North Africa (all income levels)?
Provide a succinct answer. 54. What is the ratio of the Aid flow from UN agencies (US$) in 1970 in Low & middle income to that in Middle East & North Africa (all income levels)?
Ensure brevity in your answer.  45.12. What is the ratio of the Aid flow from UN agencies (US$) in 1971 in Low & middle income to that in Middle East & North Africa (all income levels)?
Offer a very short reply. 62.14. What is the ratio of the Aid flow from UN agencies (US$) in 1972 in Low & middle income to that in Middle East & North Africa (all income levels)?
Keep it short and to the point. 48.07. What is the ratio of the Aid flow from UN agencies (US$) of 1969 in Low income to that in Lower middle income?
Offer a very short reply. 2.35. What is the ratio of the Aid flow from UN agencies (US$) in 1970 in Low income to that in Lower middle income?
Your answer should be very brief. 1.64. What is the ratio of the Aid flow from UN agencies (US$) of 1971 in Low income to that in Lower middle income?
Offer a terse response. 1.8. What is the ratio of the Aid flow from UN agencies (US$) in 1972 in Low income to that in Lower middle income?
Offer a terse response. 0.33. What is the ratio of the Aid flow from UN agencies (US$) of 1970 in Low income to that in Middle East & North Africa (all income levels)?
Keep it short and to the point. 19.29. What is the ratio of the Aid flow from UN agencies (US$) of 1971 in Low income to that in Middle East & North Africa (all income levels)?
Keep it short and to the point. 27.29. What is the ratio of the Aid flow from UN agencies (US$) of 1972 in Low income to that in Middle East & North Africa (all income levels)?
Provide a succinct answer. 10.35. What is the ratio of the Aid flow from UN agencies (US$) of 1969 in Lower middle income to that in Middle East & North Africa (all income levels)?
Make the answer very short. 11.93. What is the ratio of the Aid flow from UN agencies (US$) of 1970 in Lower middle income to that in Middle East & North Africa (all income levels)?
Make the answer very short. 11.76. What is the ratio of the Aid flow from UN agencies (US$) of 1971 in Lower middle income to that in Middle East & North Africa (all income levels)?
Your answer should be compact. 15.14. What is the ratio of the Aid flow from UN agencies (US$) in 1972 in Lower middle income to that in Middle East & North Africa (all income levels)?
Keep it short and to the point. 31.46. What is the difference between the highest and the second highest Aid flow from UN agencies (US$) of 1969?
Your response must be concise. 2.34e+06. What is the difference between the highest and the second highest Aid flow from UN agencies (US$) of 1970?
Keep it short and to the point. 2.87e+06. What is the difference between the highest and the second highest Aid flow from UN agencies (US$) of 1971?
Your response must be concise. 3.79e+06. What is the difference between the highest and the second highest Aid flow from UN agencies (US$) of 1972?
Your answer should be compact. 3.18e+06. What is the difference between the highest and the lowest Aid flow from UN agencies (US$) in 1969?
Provide a short and direct response. 7.42e+06. What is the difference between the highest and the lowest Aid flow from UN agencies (US$) of 1970?
Your answer should be compact. 7.50e+06. What is the difference between the highest and the lowest Aid flow from UN agencies (US$) in 1971?
Your answer should be very brief. 8.56e+06. What is the difference between the highest and the lowest Aid flow from UN agencies (US$) of 1972?
Offer a very short reply. 2.18e+07. 